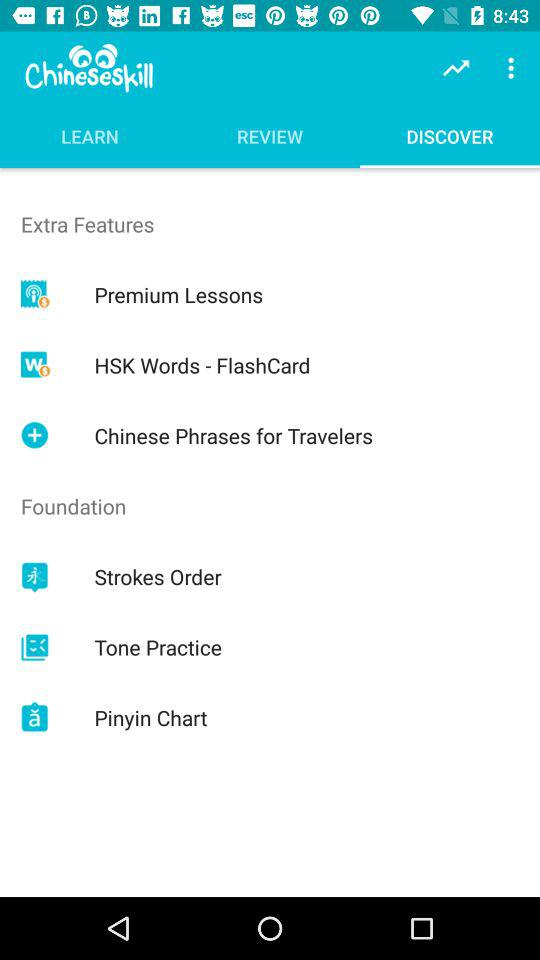What items are available in "LEARN"?
When the provided information is insufficient, respond with <no answer>. <no answer> 